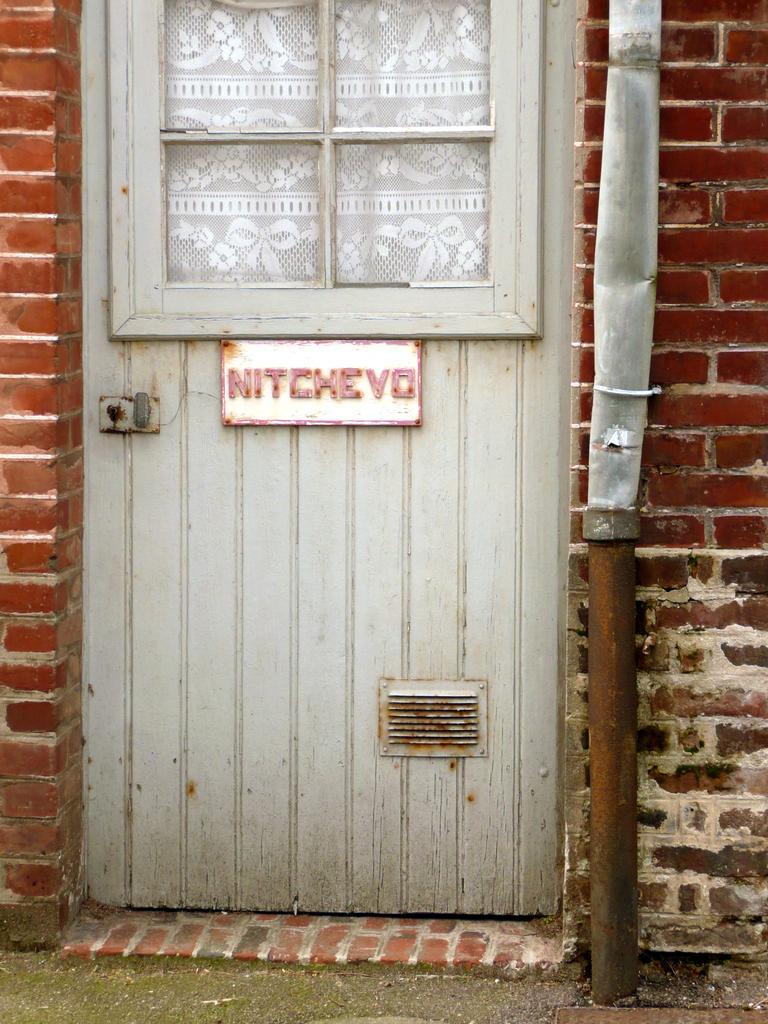Describe this image in one or two sentences. In this image, I can see a door with a door lock. This looks like a name board, which is attached to the door. I think this is a pipeline, which is attached to the wall. This wall is built with the bricks. I think this is a cloth, which is behind the door. 